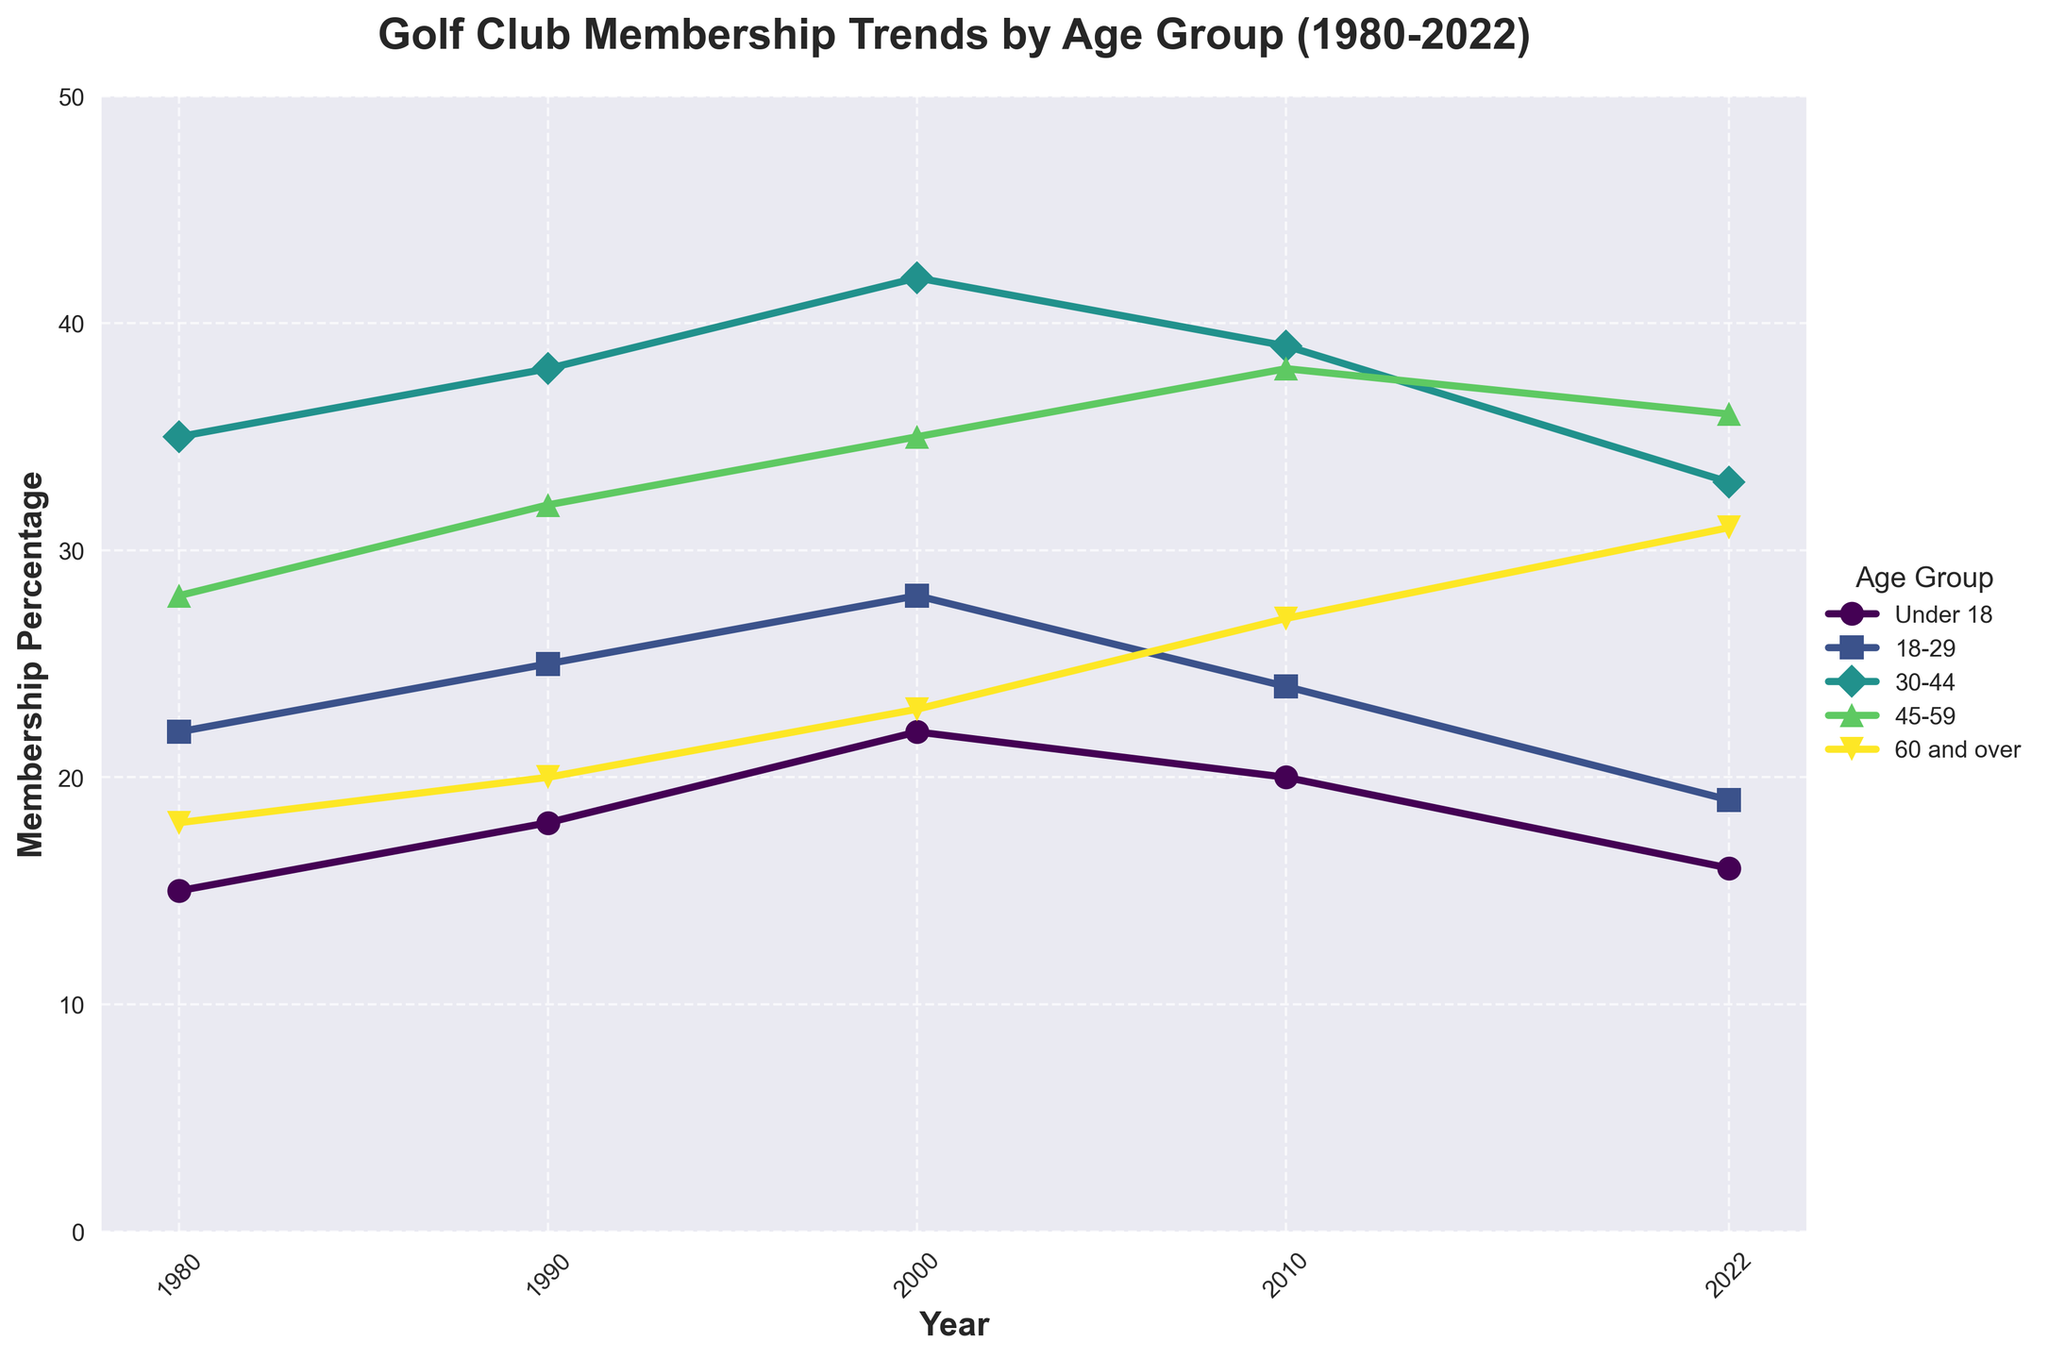what age group had the highest golf club membership percentage in 2000? In 2000, each age group's membership percentage can be compared to see which is highest. For 2000, the 30-44 age group had a membership of 42 percent, which is the highest among all age groups.
Answer: 30-44 what is the difference in membership percentage for the 45-59 age group between 1980 and 2022? To find the difference, subtract the 1980 membership percentage from the 2022 percentage for the 45-59 age group. The percentage in 2022 is 36, and in 1980 it was 28, so the difference is 36 - 28 = 8.
Answer: 8 which age group had a decreasing trend in golf club membership between 2010 and 2022? By examining the trend from 2010 to 2022 for each age group, the 18-29 group shows a decrease; membership dropped from 24 percent in 2010 to 19 percent in 2022.
Answer: 18-29 what age group had the lowest membership in 1980, and what was the percentage? In 1980, the data shows that the "Under 18" group had the lowest membership percentage at 15 percent.
Answer: Under 18, 15 how did the membership percentage of the '60 and over' age group change from 1980 to 2022? The '60 and over' age group's membership increased from 18 percent in 1980 to 31 percent in 2022. Therefore, the percentage change is 31 - 18 = 13.
Answer: Increased by 13 which age group showed the most consistent membership trend across the years? Checking the trends for all groups, the "Under 18" group experienced the least fluctuation, starting at 15 percent in 1980 and ending at 16 percent in 2022, with small fluctuations in between.
Answer: Under 18 how many age groups had their highest membership percentage in 2000, and which ones are they? By reviewing the membership percentages across the years, the age groups "Under 18," "18-29," "30-44," and "45-59" all reached peak values in 2000.
Answer: 4; Under 18, 18-29, 30-44, 45-59 what age group showed the greatest percentage increase from 1980 to 2022? Calculate the difference for each age group between 1980 and 2022, which shows the greatest increase for the '60 and over' age group, from 18 percent to 31 percent, a rise of 13 percent points.
Answer: 60 and over, 13 what was the membership percentage of '30-44' age group in 2010, and how does it compare to the '45-59' age group in the same year? In 2010, the '30-44' age group had a membership percentage of 39, while the '45-59' group had 38. Comparing these, the '30-44' group had a slightly higher percentage.
Answer: 30-44: 39, 45-59: 38 if we average the membership percentages across all age groups for the year 2022, what is the result? Sum the percentages for all age groups in 2022 and divide by the number of groups. (16 + 19 + 33 + 36 + 31) = 135, then 135 / 5 = 27.
Answer: 27 